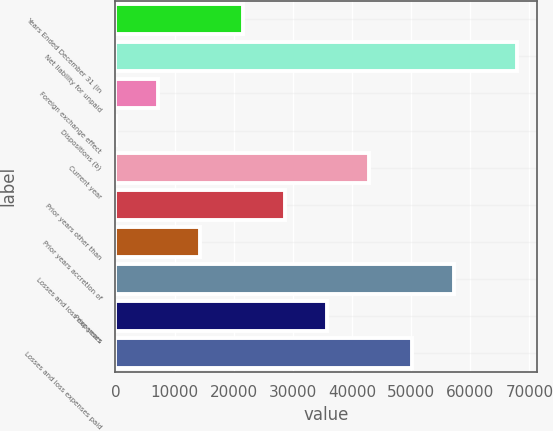<chart> <loc_0><loc_0><loc_500><loc_500><bar_chart><fcel>Years Ended December 31 (in<fcel>Net liability for unpaid<fcel>Foreign exchange effect<fcel>Dispositions (b)<fcel>Current year<fcel>Prior years other than<fcel>Prior years accretion of<fcel>Losses and loss expenses<fcel>Prior years<fcel>Losses and loss expenses paid<nl><fcel>21513<fcel>67899<fcel>7229<fcel>87<fcel>42939<fcel>28655<fcel>14371<fcel>57223<fcel>35797<fcel>50081<nl></chart> 